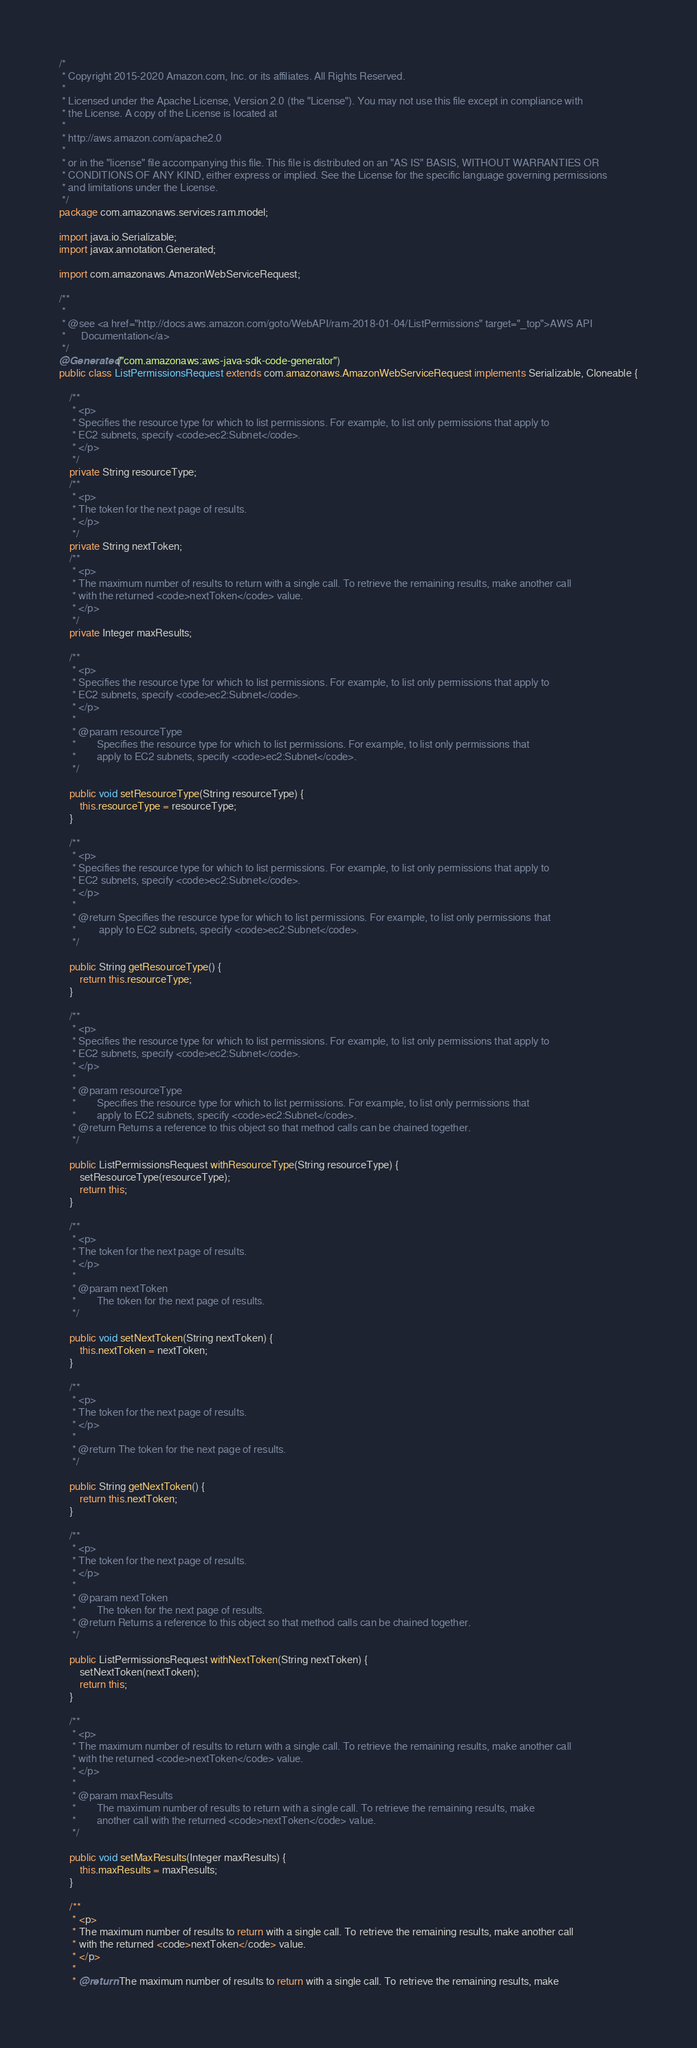Convert code to text. <code><loc_0><loc_0><loc_500><loc_500><_Java_>/*
 * Copyright 2015-2020 Amazon.com, Inc. or its affiliates. All Rights Reserved.
 * 
 * Licensed under the Apache License, Version 2.0 (the "License"). You may not use this file except in compliance with
 * the License. A copy of the License is located at
 * 
 * http://aws.amazon.com/apache2.0
 * 
 * or in the "license" file accompanying this file. This file is distributed on an "AS IS" BASIS, WITHOUT WARRANTIES OR
 * CONDITIONS OF ANY KIND, either express or implied. See the License for the specific language governing permissions
 * and limitations under the License.
 */
package com.amazonaws.services.ram.model;

import java.io.Serializable;
import javax.annotation.Generated;

import com.amazonaws.AmazonWebServiceRequest;

/**
 * 
 * @see <a href="http://docs.aws.amazon.com/goto/WebAPI/ram-2018-01-04/ListPermissions" target="_top">AWS API
 *      Documentation</a>
 */
@Generated("com.amazonaws:aws-java-sdk-code-generator")
public class ListPermissionsRequest extends com.amazonaws.AmazonWebServiceRequest implements Serializable, Cloneable {

    /**
     * <p>
     * Specifies the resource type for which to list permissions. For example, to list only permissions that apply to
     * EC2 subnets, specify <code>ec2:Subnet</code>.
     * </p>
     */
    private String resourceType;
    /**
     * <p>
     * The token for the next page of results.
     * </p>
     */
    private String nextToken;
    /**
     * <p>
     * The maximum number of results to return with a single call. To retrieve the remaining results, make another call
     * with the returned <code>nextToken</code> value.
     * </p>
     */
    private Integer maxResults;

    /**
     * <p>
     * Specifies the resource type for which to list permissions. For example, to list only permissions that apply to
     * EC2 subnets, specify <code>ec2:Subnet</code>.
     * </p>
     * 
     * @param resourceType
     *        Specifies the resource type for which to list permissions. For example, to list only permissions that
     *        apply to EC2 subnets, specify <code>ec2:Subnet</code>.
     */

    public void setResourceType(String resourceType) {
        this.resourceType = resourceType;
    }

    /**
     * <p>
     * Specifies the resource type for which to list permissions. For example, to list only permissions that apply to
     * EC2 subnets, specify <code>ec2:Subnet</code>.
     * </p>
     * 
     * @return Specifies the resource type for which to list permissions. For example, to list only permissions that
     *         apply to EC2 subnets, specify <code>ec2:Subnet</code>.
     */

    public String getResourceType() {
        return this.resourceType;
    }

    /**
     * <p>
     * Specifies the resource type for which to list permissions. For example, to list only permissions that apply to
     * EC2 subnets, specify <code>ec2:Subnet</code>.
     * </p>
     * 
     * @param resourceType
     *        Specifies the resource type for which to list permissions. For example, to list only permissions that
     *        apply to EC2 subnets, specify <code>ec2:Subnet</code>.
     * @return Returns a reference to this object so that method calls can be chained together.
     */

    public ListPermissionsRequest withResourceType(String resourceType) {
        setResourceType(resourceType);
        return this;
    }

    /**
     * <p>
     * The token for the next page of results.
     * </p>
     * 
     * @param nextToken
     *        The token for the next page of results.
     */

    public void setNextToken(String nextToken) {
        this.nextToken = nextToken;
    }

    /**
     * <p>
     * The token for the next page of results.
     * </p>
     * 
     * @return The token for the next page of results.
     */

    public String getNextToken() {
        return this.nextToken;
    }

    /**
     * <p>
     * The token for the next page of results.
     * </p>
     * 
     * @param nextToken
     *        The token for the next page of results.
     * @return Returns a reference to this object so that method calls can be chained together.
     */

    public ListPermissionsRequest withNextToken(String nextToken) {
        setNextToken(nextToken);
        return this;
    }

    /**
     * <p>
     * The maximum number of results to return with a single call. To retrieve the remaining results, make another call
     * with the returned <code>nextToken</code> value.
     * </p>
     * 
     * @param maxResults
     *        The maximum number of results to return with a single call. To retrieve the remaining results, make
     *        another call with the returned <code>nextToken</code> value.
     */

    public void setMaxResults(Integer maxResults) {
        this.maxResults = maxResults;
    }

    /**
     * <p>
     * The maximum number of results to return with a single call. To retrieve the remaining results, make another call
     * with the returned <code>nextToken</code> value.
     * </p>
     * 
     * @return The maximum number of results to return with a single call. To retrieve the remaining results, make</code> 